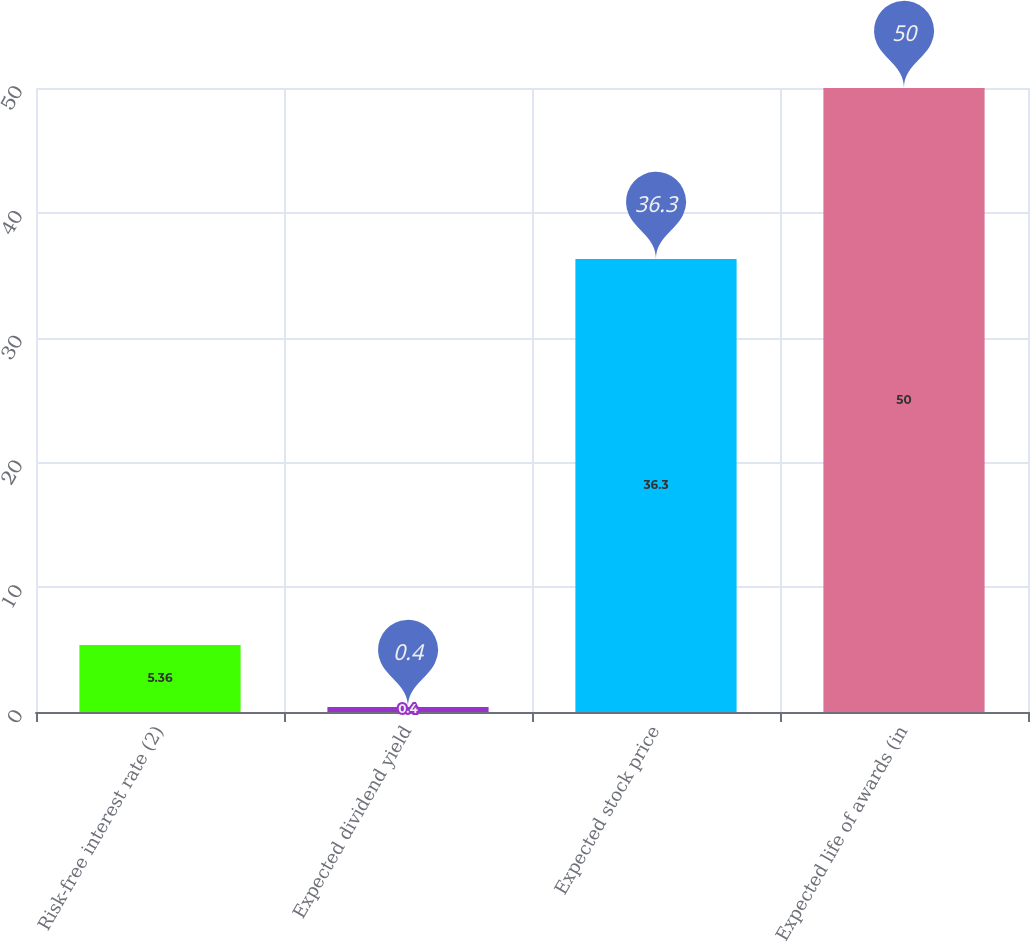<chart> <loc_0><loc_0><loc_500><loc_500><bar_chart><fcel>Risk-free interest rate (2)<fcel>Expected dividend yield<fcel>Expected stock price<fcel>Expected life of awards (in<nl><fcel>5.36<fcel>0.4<fcel>36.3<fcel>50<nl></chart> 